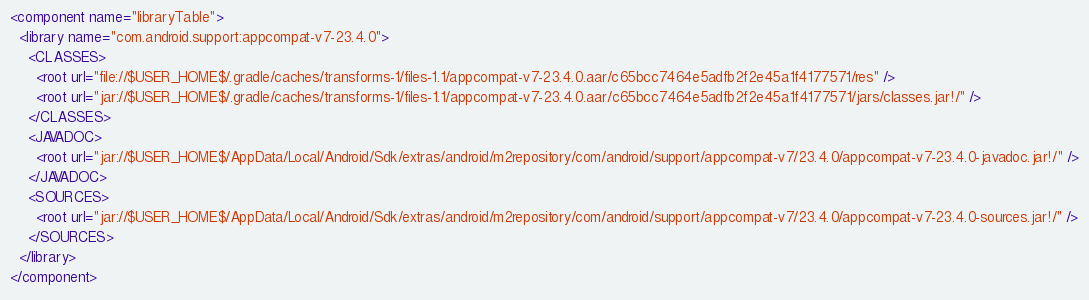Convert code to text. <code><loc_0><loc_0><loc_500><loc_500><_XML_><component name="libraryTable">
  <library name="com.android.support:appcompat-v7-23.4.0">
    <CLASSES>
      <root url="file://$USER_HOME$/.gradle/caches/transforms-1/files-1.1/appcompat-v7-23.4.0.aar/c65bcc7464e5adfb2f2e45a1f4177571/res" />
      <root url="jar://$USER_HOME$/.gradle/caches/transforms-1/files-1.1/appcompat-v7-23.4.0.aar/c65bcc7464e5adfb2f2e45a1f4177571/jars/classes.jar!/" />
    </CLASSES>
    <JAVADOC>
      <root url="jar://$USER_HOME$/AppData/Local/Android/Sdk/extras/android/m2repository/com/android/support/appcompat-v7/23.4.0/appcompat-v7-23.4.0-javadoc.jar!/" />
    </JAVADOC>
    <SOURCES>
      <root url="jar://$USER_HOME$/AppData/Local/Android/Sdk/extras/android/m2repository/com/android/support/appcompat-v7/23.4.0/appcompat-v7-23.4.0-sources.jar!/" />
    </SOURCES>
  </library>
</component></code> 